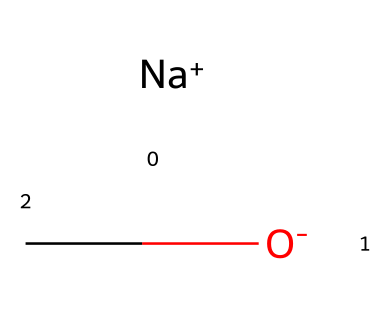What is the central atom in this alkoxide structure? The central atom in the structure is the oxygen atom, as it is connected to the alkyl group and carries a negative charge, characteristic of alkoxides.
Answer: oxygen How many total atoms are in the molecule represented by this SMILES? In the SMILES representation, there are three atoms: one sodium, one oxygen, and one carbon from the alkoxide group, giving a total of three atoms.
Answer: three What type of bond connects the oxygen atom to the carbon atom? The bond connecting the oxygen atom to the carbon atom is a single covalent bond, as indicated by the structure of the alkoxide which forms through direct connection.
Answer: single bond Which element contributes the positive charge in this alkoxide? The sodium (Na) contributes the positive charge in the structure, indicated by its representation as [Na+].
Answer: sodium What role does the oxygen atom play in organic synthesis as part of this alkoxide? The oxygen atom in the alkoxide acts as a strong nucleophile due to its negative charge, making it highly reactive in organic synthesis.
Answer: nucleophile What type of chemical is represented by this structure? The structure represents an alkoxide, which is a specific type of inorganic superbase used in various synthetic reactions.
Answer: alkoxide How does the presence of the sodium ion affect the reactivity of the alkoxide? The presence of the sodium ion stabilizes the negative charge on the oxygen, enhancing the reactivity of the alkoxide by allowing it to readily participate in substitution or elimination reactions.
Answer: enhances reactivity 